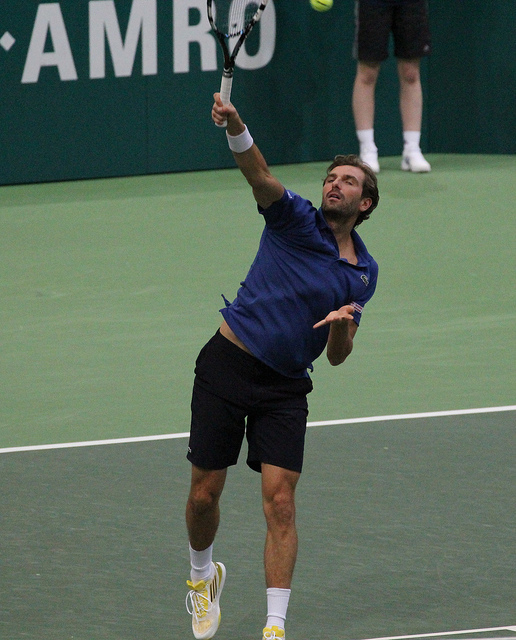<image>What brand of shirt is the man in the background wearing? I don't know what brand of shirt the man in the background is wearing. It could be 'nike', 'adidas', 'polo shirt', or 'levis'. What brand is the man's shirt? I don't know the brand of the man's shirt. It could be 'adidas', 'izod', 'nike', 'lacoste', 'polo' or 'wilson'. What brand's symbol is on the purple shirt? I am not sure about the brand's symbol on the purple shirt. It can be 'nike', 'adidas' or 'lacoste'. What brand of shirt is the man in the background wearing? I don't know what brand of shirt the man in the background is wearing. It could be Nike, Adidas, or Levis. What brand is the man's shirt? I don't know the brand of the man's shirt. It can be seen 'adidas', 'izod', 'nike', 'lacoste', 'polo' or 'wilson'. What brand's symbol is on the purple shirt? I am not sure what brand's symbol is on the purple shirt. But it can be seen 'nike', 'adidas' or 'lacoste'. 